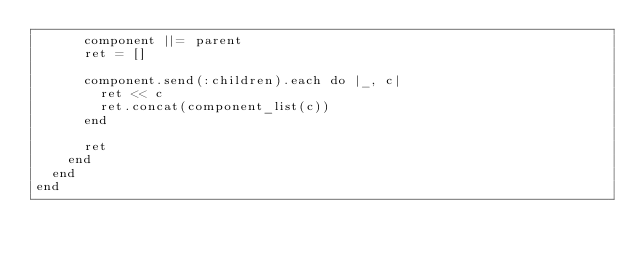Convert code to text. <code><loc_0><loc_0><loc_500><loc_500><_Ruby_>      component ||= parent
      ret = []

      component.send(:children).each do |_, c|
        ret << c
        ret.concat(component_list(c))
      end

      ret
    end
  end
end
</code> 